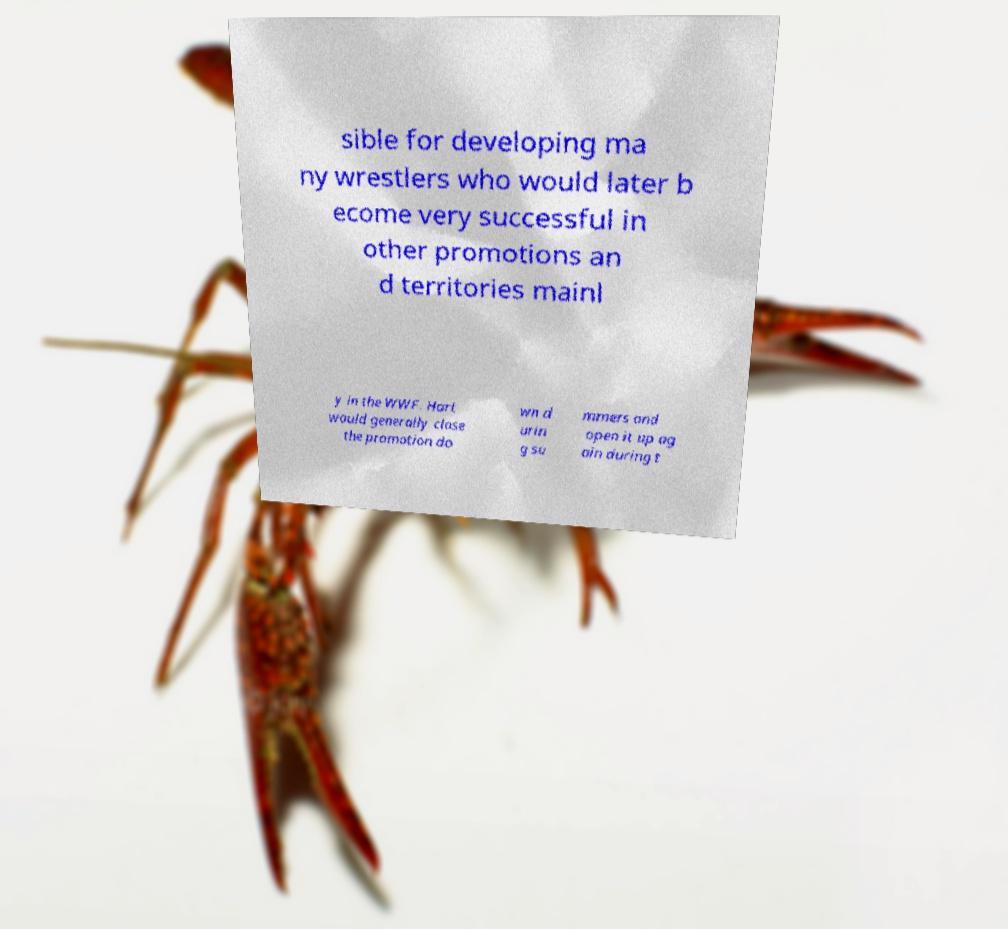Please read and relay the text visible in this image. What does it say? sible for developing ma ny wrestlers who would later b ecome very successful in other promotions an d territories mainl y in the WWF. Hart would generally close the promotion do wn d urin g su mmers and open it up ag ain during t 